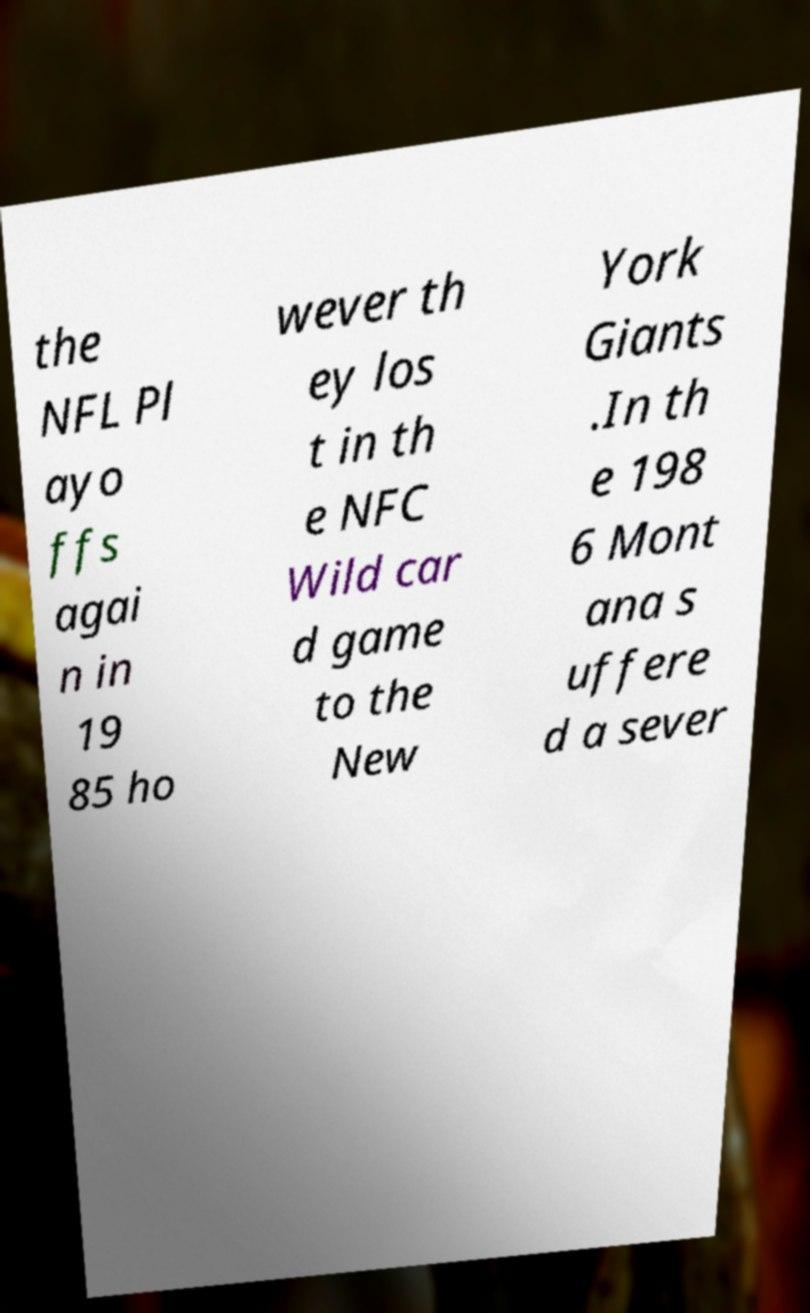For documentation purposes, I need the text within this image transcribed. Could you provide that? the NFL Pl ayo ffs agai n in 19 85 ho wever th ey los t in th e NFC Wild car d game to the New York Giants .In th e 198 6 Mont ana s uffere d a sever 